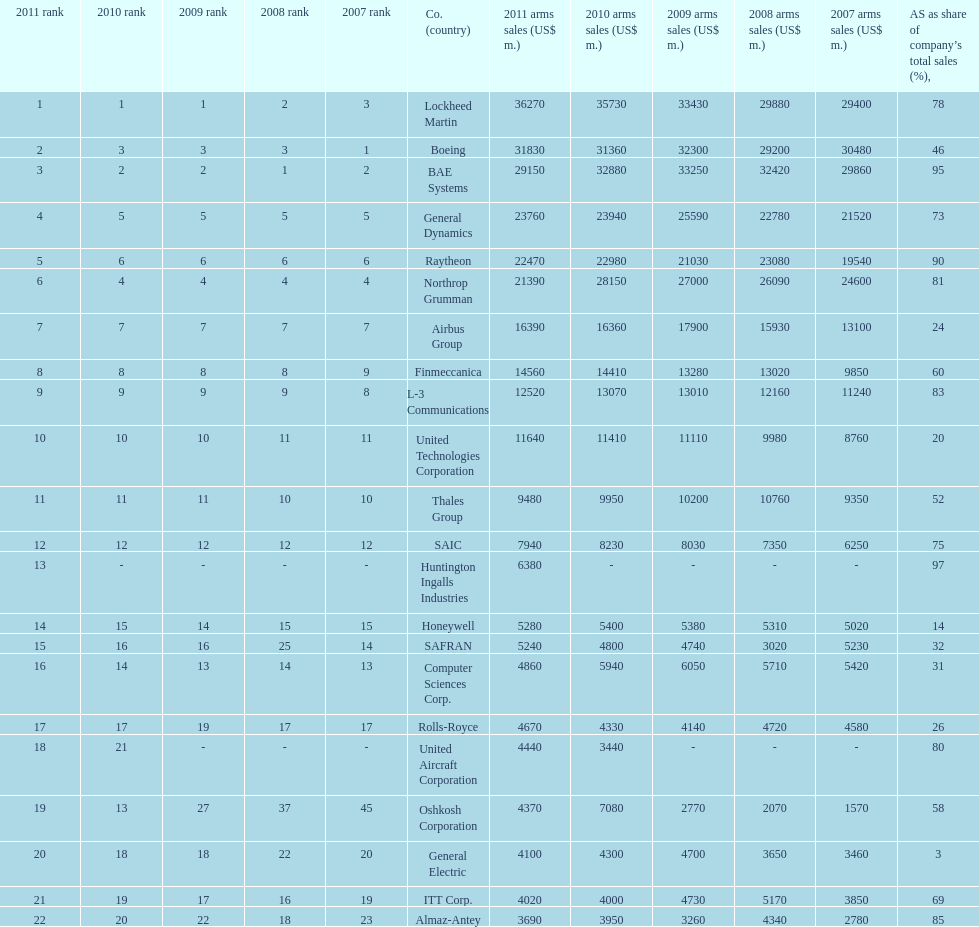Calculate the difference between boeing's 2010 arms sales and raytheon's 2010 arms sales. 8380. 